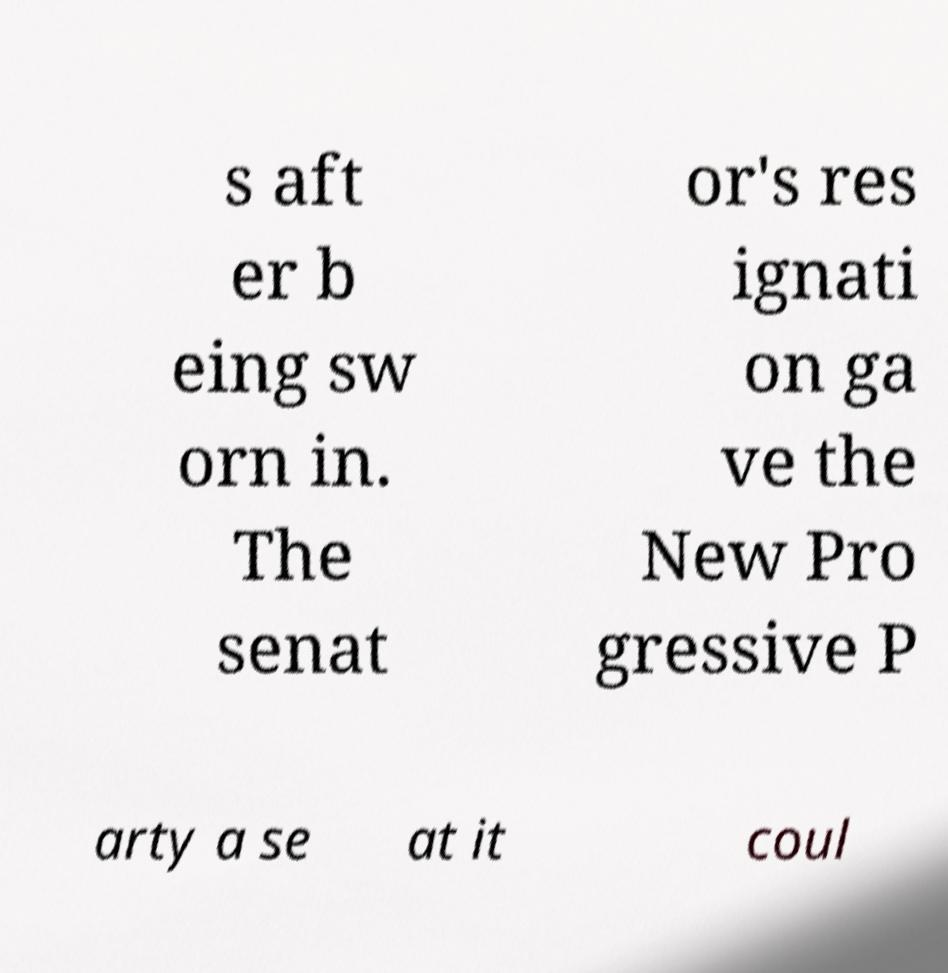Can you read and provide the text displayed in the image?This photo seems to have some interesting text. Can you extract and type it out for me? s aft er b eing sw orn in. The senat or's res ignati on ga ve the New Pro gressive P arty a se at it coul 